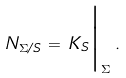<formula> <loc_0><loc_0><loc_500><loc_500>N _ { \Sigma / S } \, = \, K _ { S } \Big | _ { \Sigma } \, .</formula> 